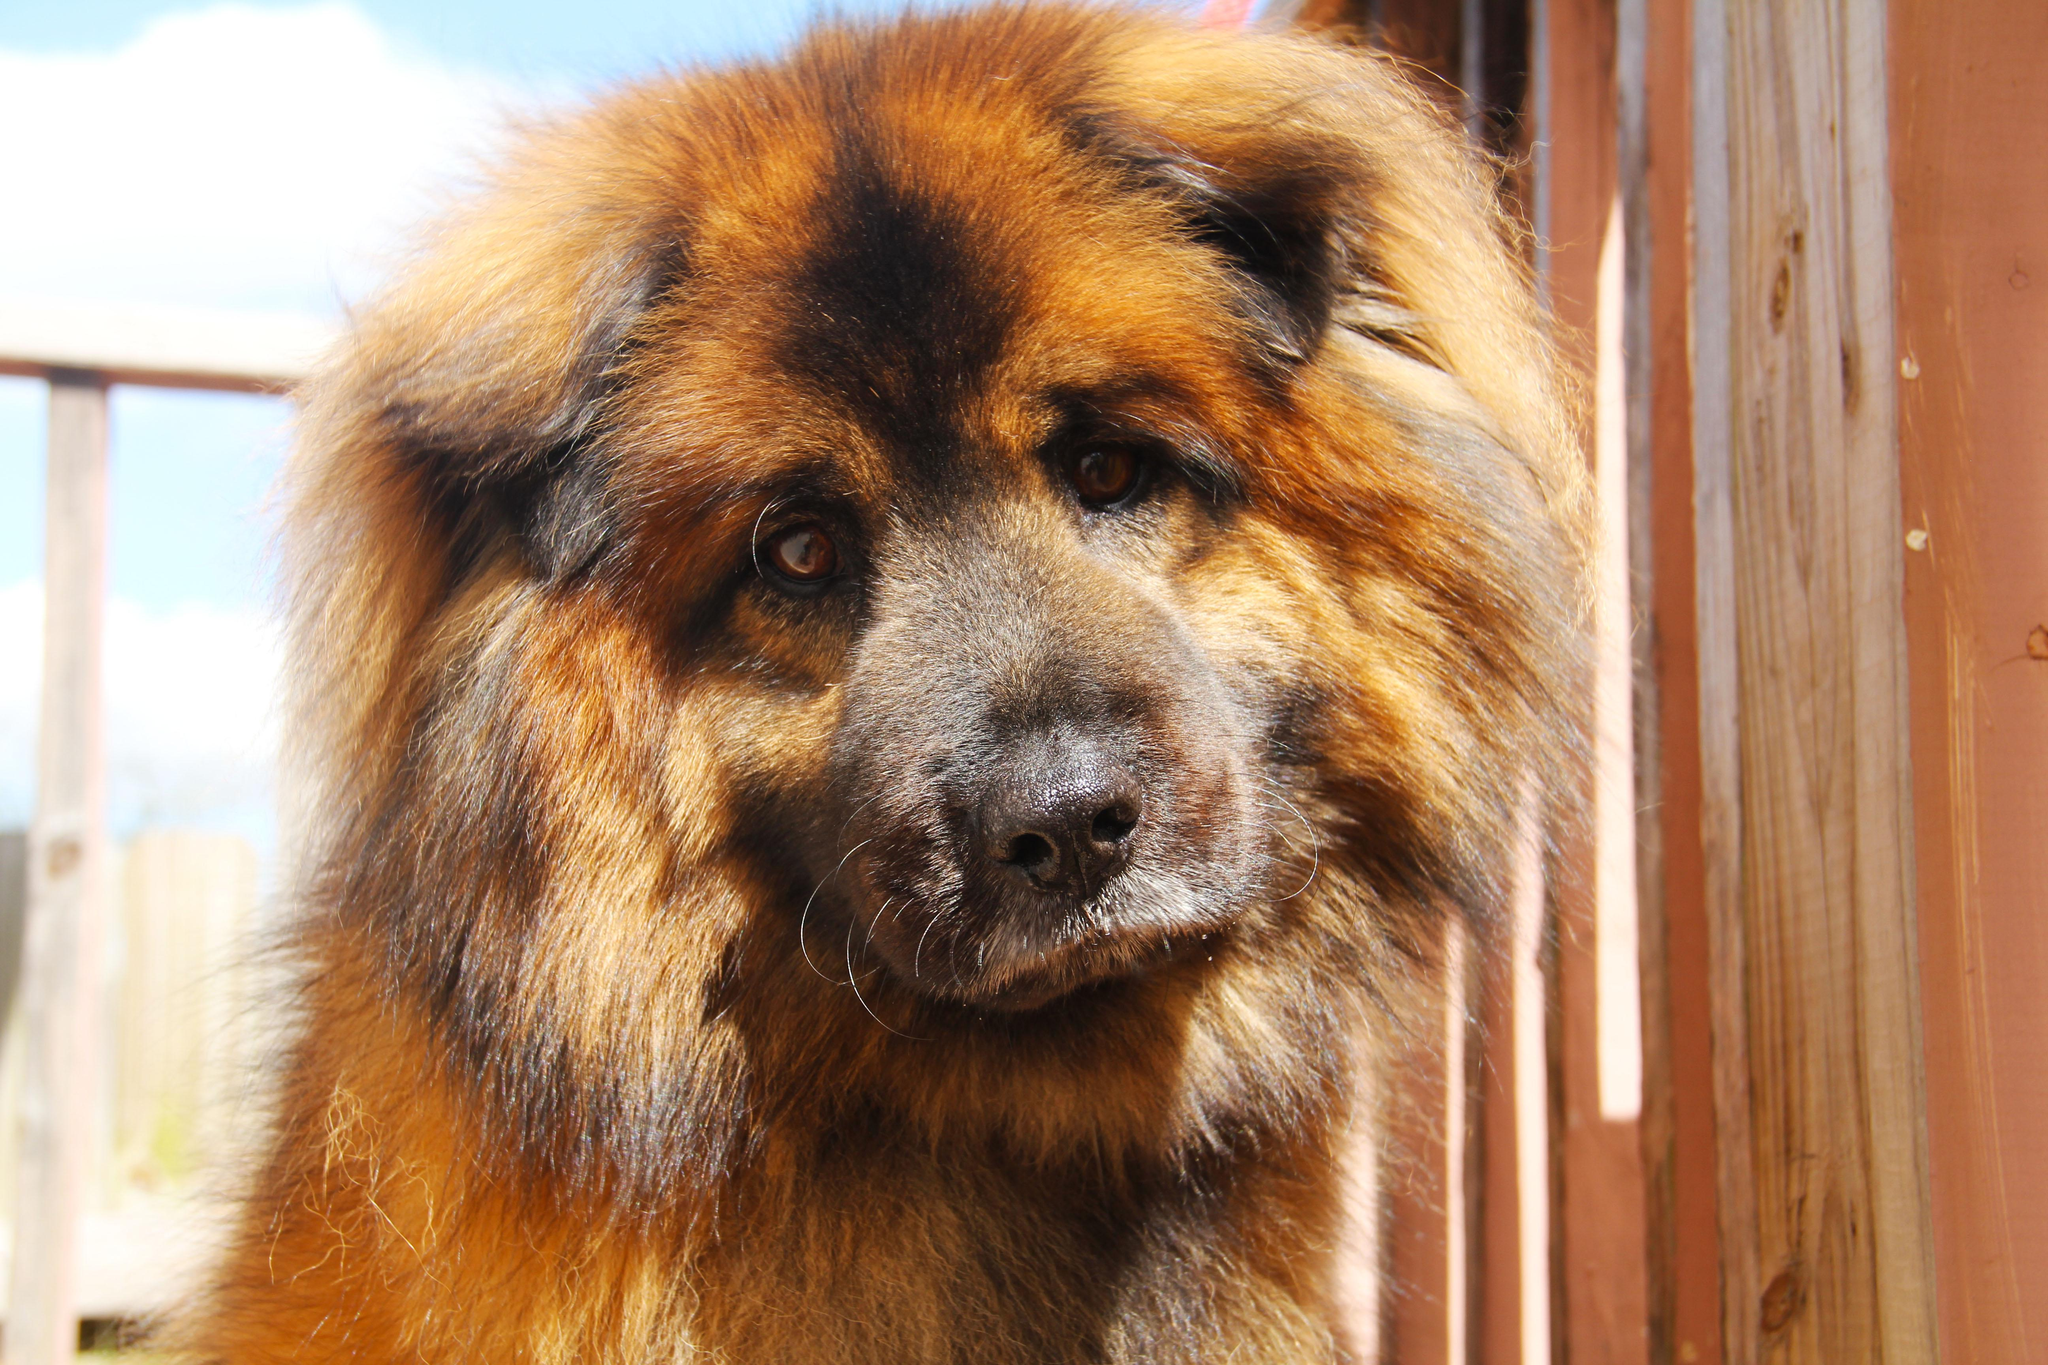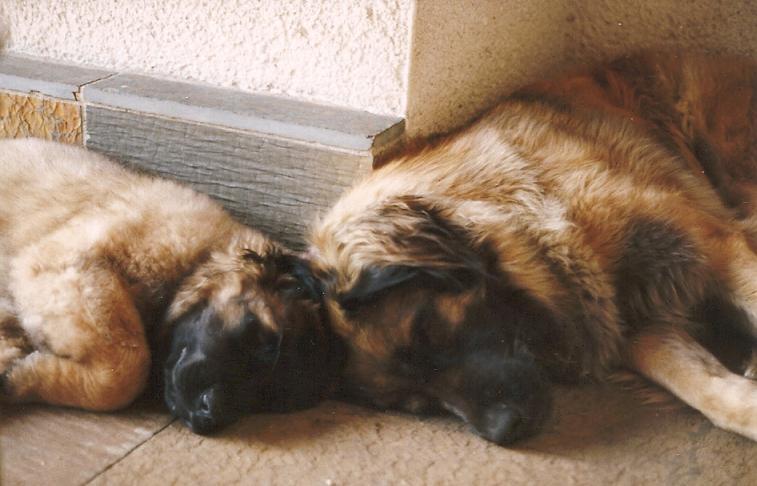The first image is the image on the left, the second image is the image on the right. Evaluate the accuracy of this statement regarding the images: "Two dogs wearing something around their necks are posed side-by-side outdoors in front of yellow foliage.". Is it true? Answer yes or no. No. 